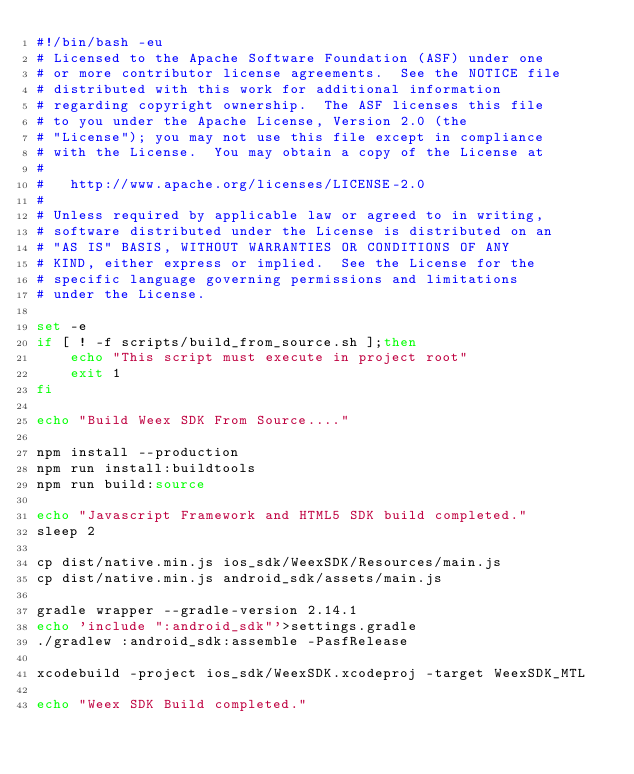<code> <loc_0><loc_0><loc_500><loc_500><_Bash_>#!/bin/bash -eu
# Licensed to the Apache Software Foundation (ASF) under one
# or more contributor license agreements.  See the NOTICE file
# distributed with this work for additional information
# regarding copyright ownership.  The ASF licenses this file
# to you under the Apache License, Version 2.0 (the
# "License"); you may not use this file except in compliance
# with the License.  You may obtain a copy of the License at
# 
#   http://www.apache.org/licenses/LICENSE-2.0
# 
# Unless required by applicable law or agreed to in writing,
# software distributed under the License is distributed on an
# "AS IS" BASIS, WITHOUT WARRANTIES OR CONDITIONS OF ANY
# KIND, either express or implied.  See the License for the
# specific language governing permissions and limitations
# under the License.

set -e
if [ ! -f scripts/build_from_source.sh ];then
    echo "This script must execute in project root"
    exit 1
fi

echo "Build Weex SDK From Source...."

npm install --production
npm run install:buildtools
npm run build:source

echo "Javascript Framework and HTML5 SDK build completed."
sleep 2

cp dist/native.min.js ios_sdk/WeexSDK/Resources/main.js
cp dist/native.min.js android_sdk/assets/main.js

gradle wrapper --gradle-version 2.14.1
echo 'include ":android_sdk"'>settings.gradle
./gradlew :android_sdk:assemble -PasfRelease

xcodebuild -project ios_sdk/WeexSDK.xcodeproj -target WeexSDK_MTL

echo "Weex SDK Build completed."</code> 